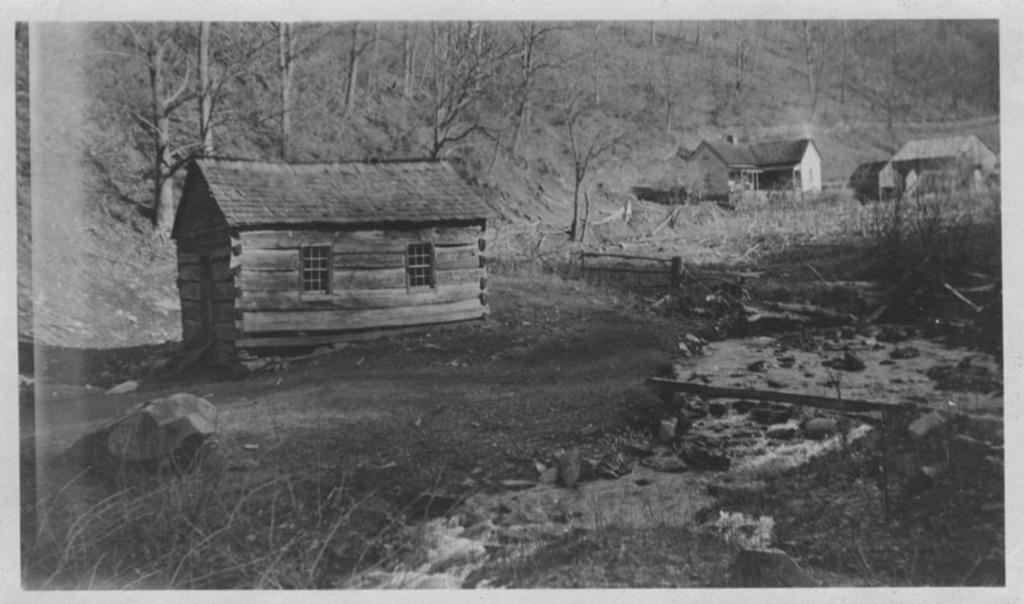What type of natural elements can be seen in the image? There are stones, grass, water, and trees in the background of the image. What type of structures are present in the image? There are houses in the image. What features can be observed on the houses? There are windows in the image. What additional objects can be seen in the image? There are wooden logs and other objects in the image. What type of pet can be seen playing with the stove in the image? There is no pet or stove present in the image. 